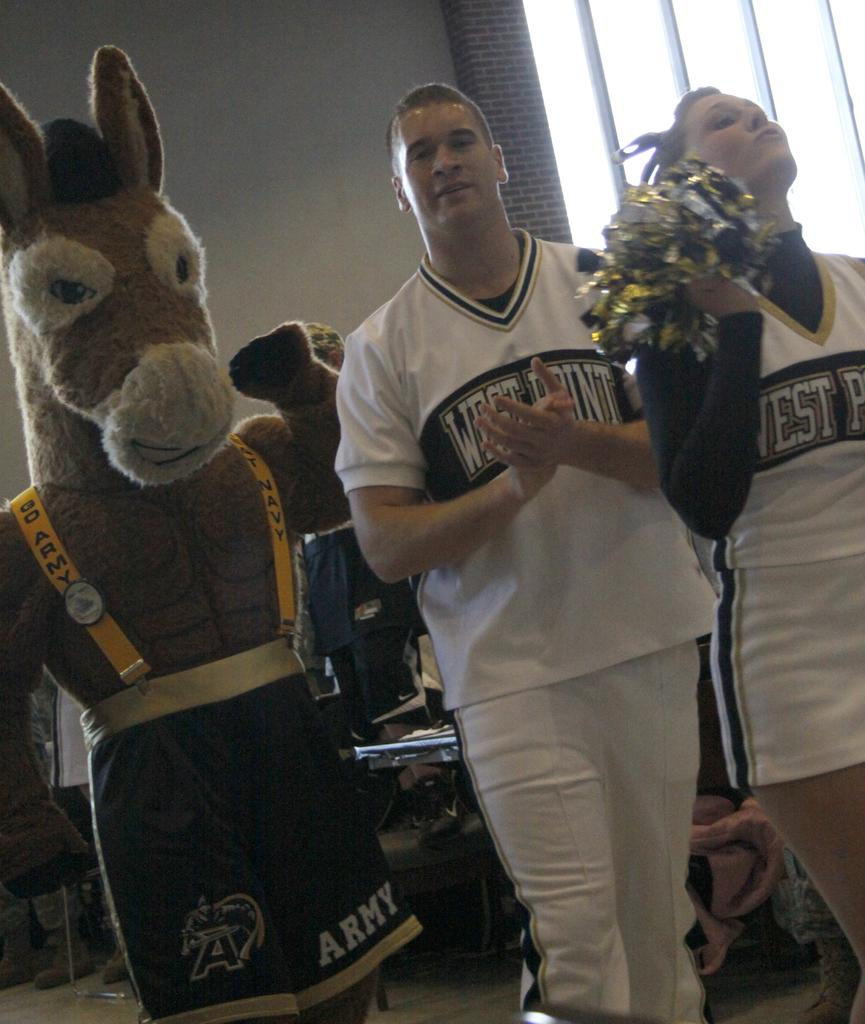<image>
Relay a brief, clear account of the picture shown. a few people from a school team with one that has a west point shirt on 